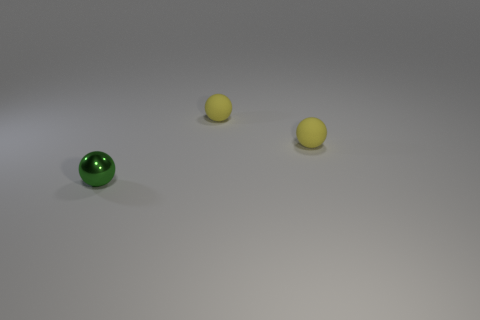Add 3 small metal cylinders. How many objects exist? 6 Subtract 0 red cylinders. How many objects are left? 3 Subtract all small yellow objects. Subtract all tiny green shiny spheres. How many objects are left? 0 Add 3 tiny rubber balls. How many tiny rubber balls are left? 5 Add 1 balls. How many balls exist? 4 